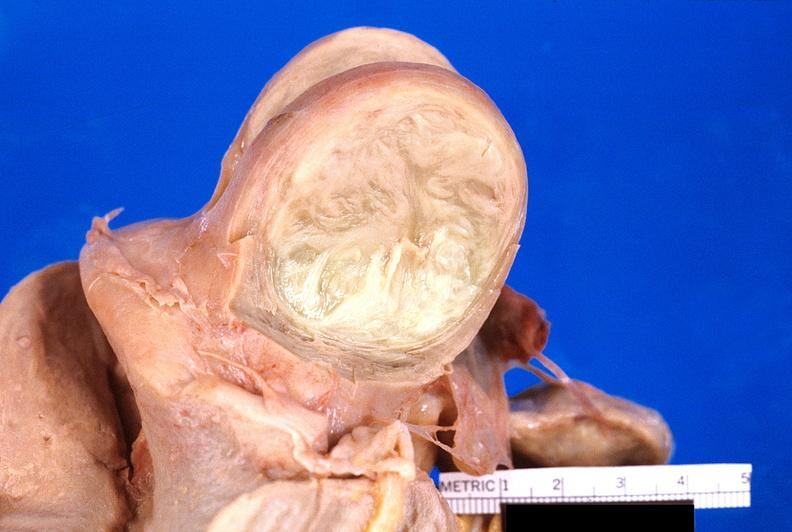does this image show uterus, leiomyoma?
Answer the question using a single word or phrase. Yes 